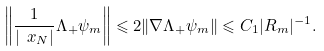Convert formula to latex. <formula><loc_0><loc_0><loc_500><loc_500>\left \| \frac { 1 } { | \ x _ { N } | } \Lambda _ { + } \psi _ { m } \right \| \leqslant 2 \| \nabla \Lambda _ { + } \psi _ { m } \| \leqslant C _ { 1 } | R _ { m } | ^ { - 1 } .</formula> 